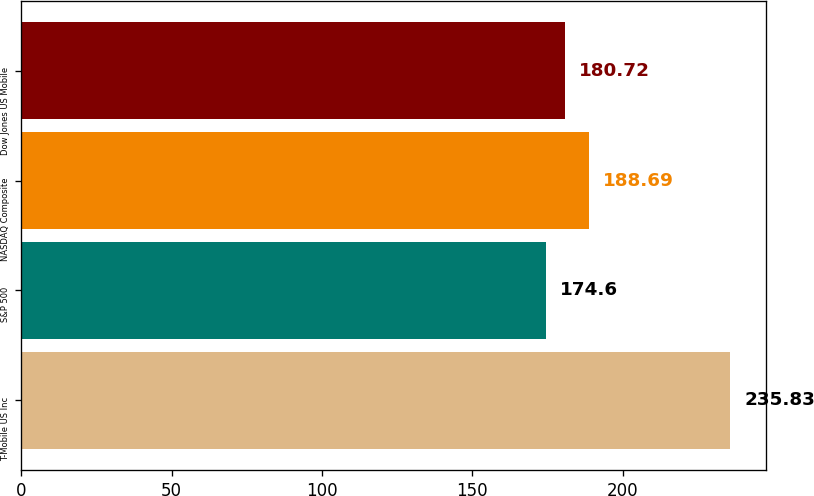Convert chart to OTSL. <chart><loc_0><loc_0><loc_500><loc_500><bar_chart><fcel>T-Mobile US Inc<fcel>S&P 500<fcel>NASDAQ Composite<fcel>Dow Jones US Mobile<nl><fcel>235.83<fcel>174.6<fcel>188.69<fcel>180.72<nl></chart> 